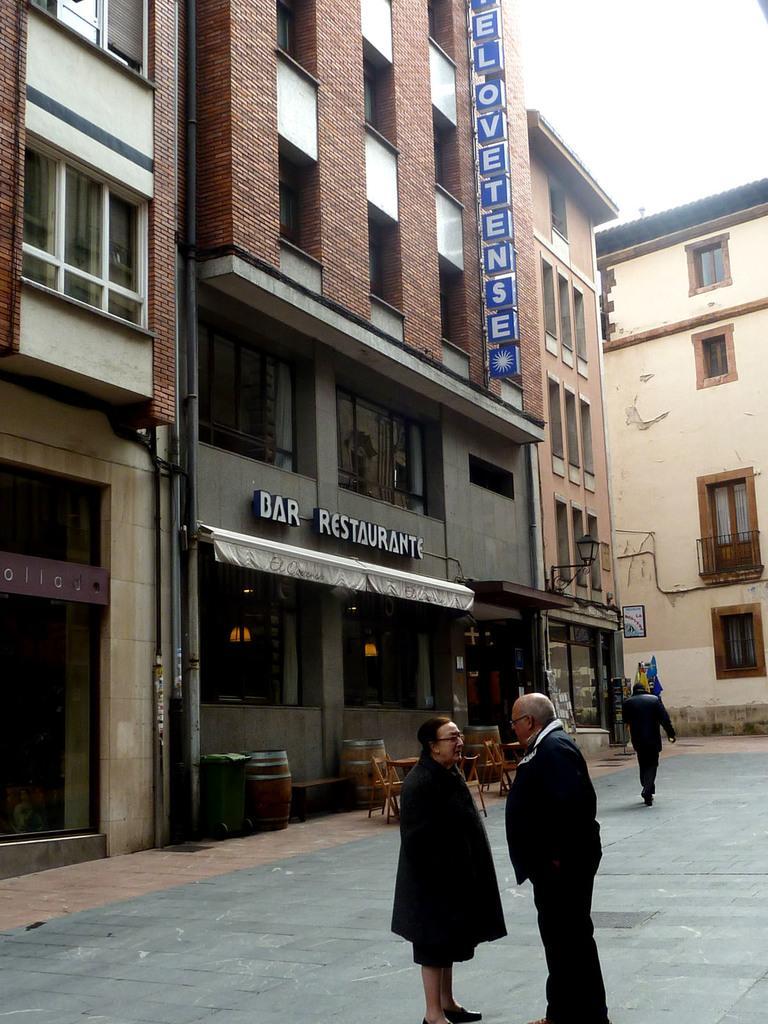Can you describe this image briefly? In this image there are few buildings in front of that there are some people standing on road, also there are chairs and tables under the tent in front of building. 